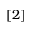Convert formula to latex. <formula><loc_0><loc_0><loc_500><loc_500>[ 2 ]</formula> 